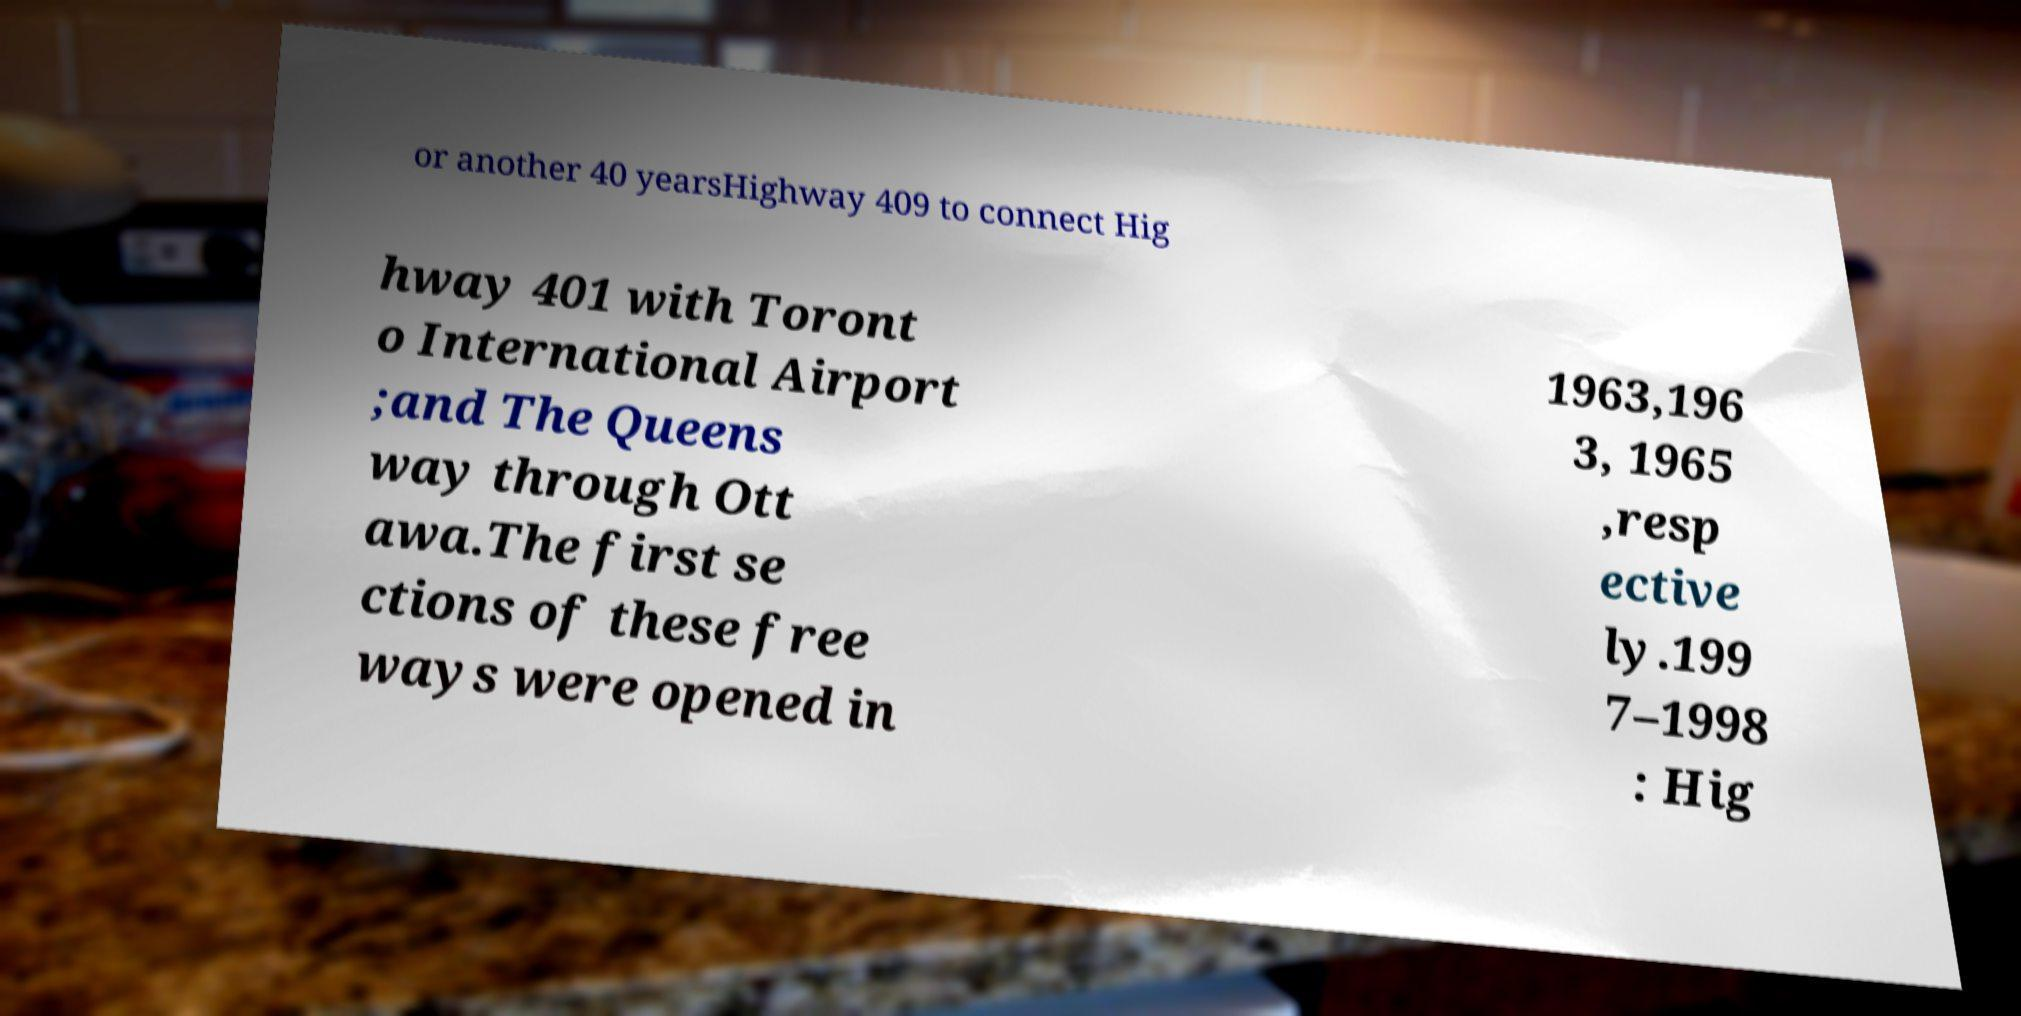I need the written content from this picture converted into text. Can you do that? or another 40 yearsHighway 409 to connect Hig hway 401 with Toront o International Airport ;and The Queens way through Ott awa.The first se ctions of these free ways were opened in 1963,196 3, 1965 ,resp ective ly.199 7–1998 : Hig 